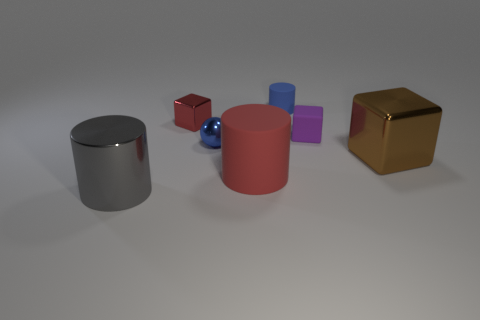Is the number of big matte cylinders in front of the blue rubber cylinder less than the number of tiny balls?
Provide a succinct answer. No. There is a brown metal thing that is the same size as the red matte object; what is its shape?
Provide a succinct answer. Cube. How many other objects are there of the same color as the metallic cylinder?
Ensure brevity in your answer.  0. Does the sphere have the same size as the gray shiny cylinder?
Your response must be concise. No. What number of things are red cylinders or matte objects left of the small cylinder?
Keep it short and to the point. 1. Is the number of tiny purple cubes that are right of the tiny cylinder less than the number of blocks left of the big cube?
Give a very brief answer. Yes. How many other things are there of the same material as the blue cylinder?
Your answer should be very brief. 2. There is a tiny shiny thing that is on the right side of the red metallic cube; is its color the same as the small rubber block?
Provide a succinct answer. No. There is a tiny matte thing to the left of the rubber cube; are there any cylinders that are on the right side of it?
Offer a very short reply. No. What is the block that is both to the right of the blue metallic thing and behind the large cube made of?
Your response must be concise. Rubber. 